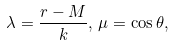<formula> <loc_0><loc_0><loc_500><loc_500>\lambda = \frac { r - M } { k } , \, \mu = \cos \theta ,</formula> 